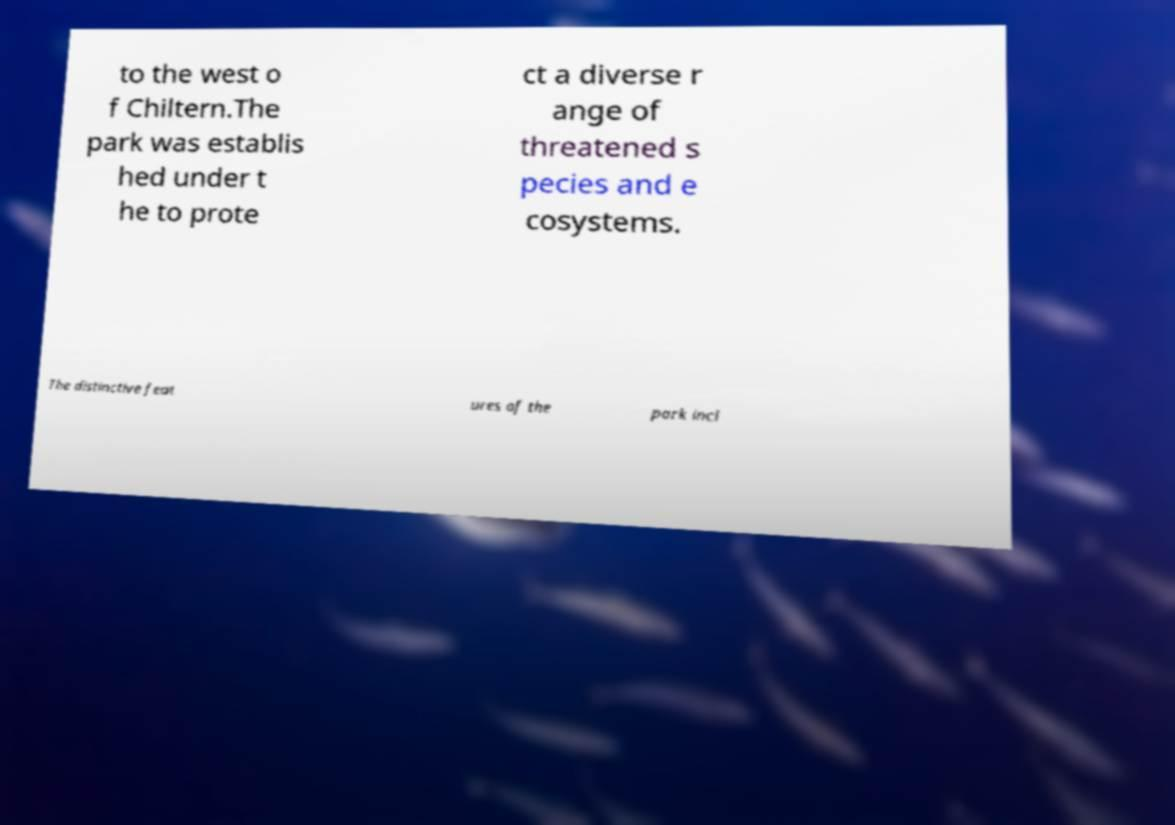I need the written content from this picture converted into text. Can you do that? to the west o f Chiltern.The park was establis hed under t he to prote ct a diverse r ange of threatened s pecies and e cosystems. The distinctive feat ures of the park incl 